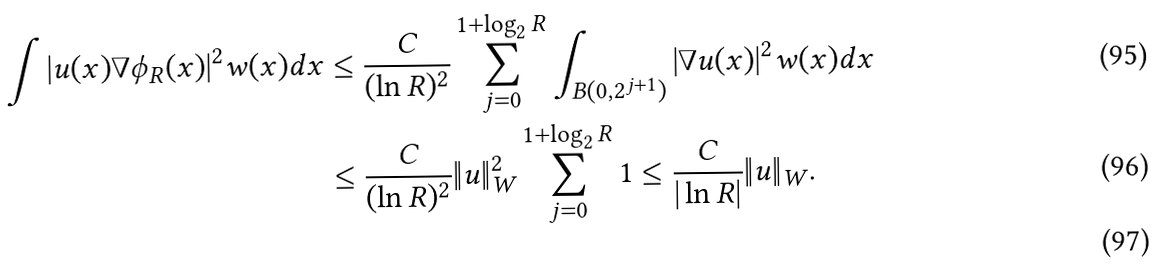<formula> <loc_0><loc_0><loc_500><loc_500>\int | u ( x ) \nabla \phi _ { R } ( x ) | ^ { 2 } w ( x ) d x & \leq \frac { C } { ( \ln R ) ^ { 2 } } \sum _ { j = 0 } ^ { 1 + \log _ { 2 } R } \int _ { B ( 0 , 2 ^ { j + 1 } ) } | \nabla u ( x ) | ^ { 2 } w ( x ) d x \\ & \leq \frac { C } { ( \ln R ) ^ { 2 } } \| u \| _ { W } ^ { 2 } \sum _ { j = 0 } ^ { 1 + \log _ { 2 } R } 1 \leq \frac { C } { | \ln R | } \| u \| _ { W } . \\</formula> 